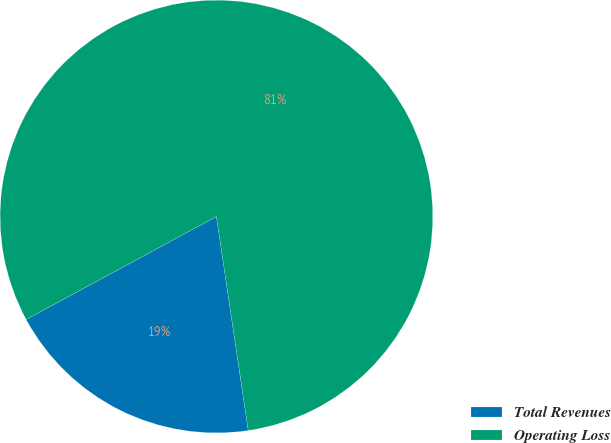Convert chart. <chart><loc_0><loc_0><loc_500><loc_500><pie_chart><fcel>Total Revenues<fcel>Operating Loss<nl><fcel>19.46%<fcel>80.54%<nl></chart> 